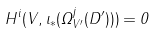<formula> <loc_0><loc_0><loc_500><loc_500>H ^ { i } ( V , \iota _ { * } ( \Omega ^ { j } _ { V ^ { \prime } } ( D ^ { \prime } ) ) ) = 0</formula> 